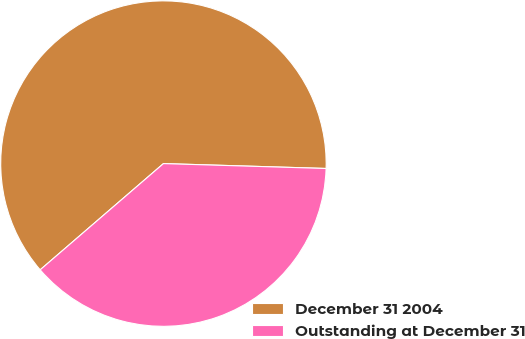Convert chart. <chart><loc_0><loc_0><loc_500><loc_500><pie_chart><fcel>December 31 2004<fcel>Outstanding at December 31<nl><fcel>61.8%<fcel>38.2%<nl></chart> 